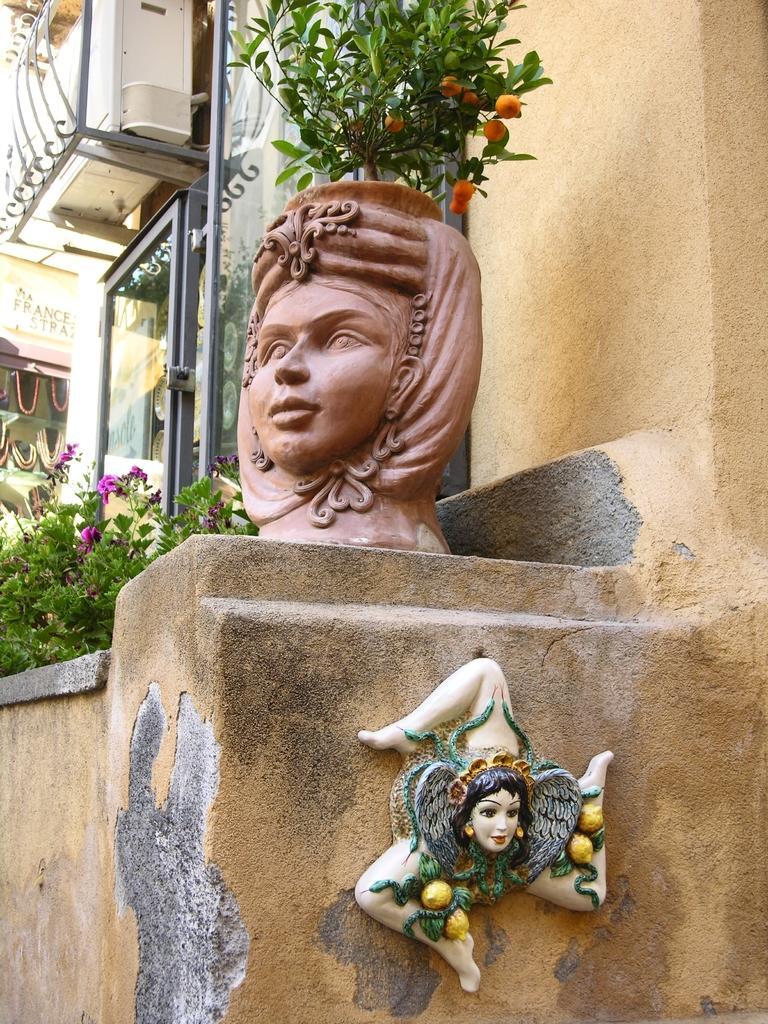Please provide a concise description of this image. In this image I can see the cream colored wall, a flower pot which is in the shape of human face, few plants, few flowers which are orange and pink in color, a sculpture to the wall and in the background I can see few buildings and the white colored object. 